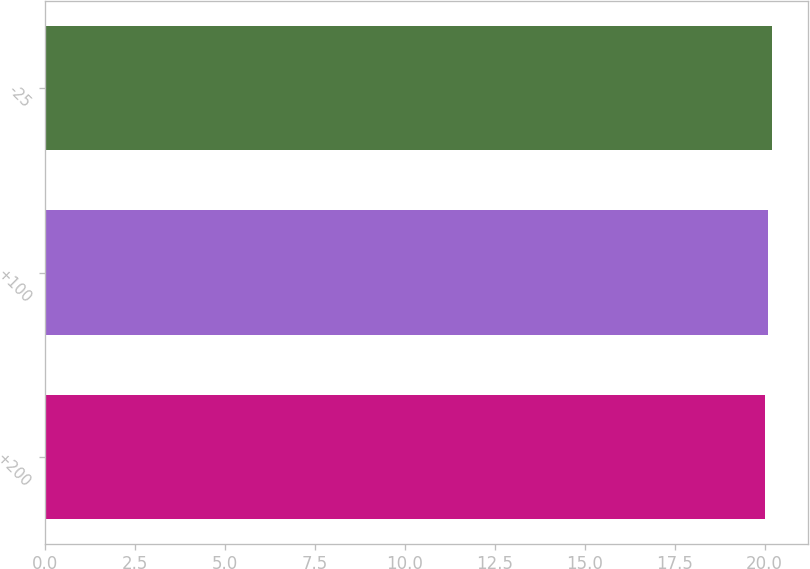<chart> <loc_0><loc_0><loc_500><loc_500><bar_chart><fcel>+200<fcel>+100<fcel>-25<nl><fcel>20<fcel>20.1<fcel>20.2<nl></chart> 